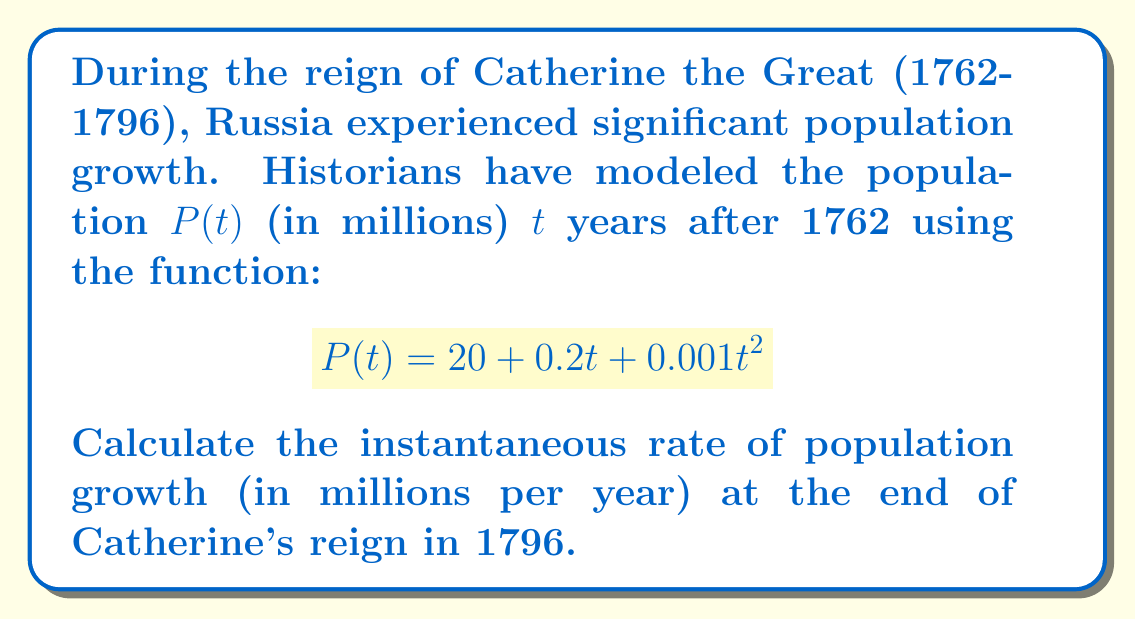Teach me how to tackle this problem. To solve this problem, we need to follow these steps:

1) The instantaneous rate of change is given by the derivative of the function at a specific point. We need to find $P'(t)$.

2) To find $P'(t)$, we differentiate $P(t)$ with respect to $t$:
   $$P'(t) = \frac{d}{dt}(20 + 0.2t + 0.001t^2)$$
   $$P'(t) = 0 + 0.2 + 0.002t$$

3) Catherine's reign ended in 1796, which is 34 years after 1762. So we need to evaluate $P'(34)$:
   $$P'(34) = 0.2 + 0.002(34)$$
   $$P'(34) = 0.2 + 0.068$$
   $$P'(34) = 0.268$$

4) This result represents the instantaneous rate of population growth in millions per year at the end of Catherine's reign.
Answer: 0.268 million per year 